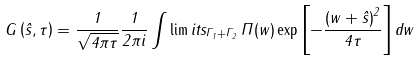Convert formula to latex. <formula><loc_0><loc_0><loc_500><loc_500>G \left ( \hat { s } , \tau \right ) = \frac { 1 } { \sqrt { 4 \pi \tau } } \frac { 1 } { 2 \pi i } \int \lim i t s _ { \Gamma _ { 1 } + \Gamma _ { 2 } } \, \Pi ( w ) \exp { \left [ - \frac { \left ( w + \hat { s } \right ) ^ { 2 } } { 4 \tau } \right ] } \, d w</formula> 